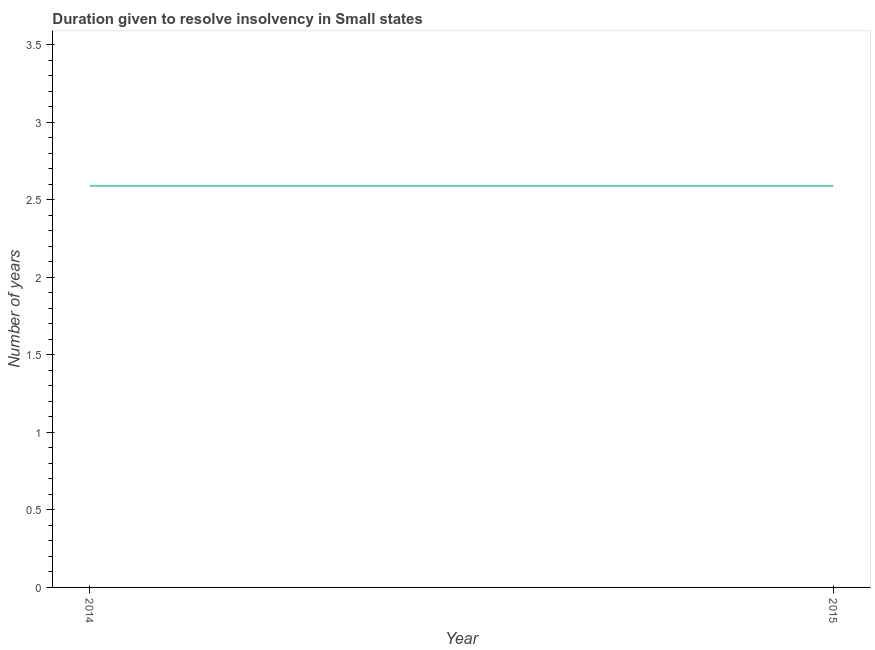What is the number of years to resolve insolvency in 2015?
Your answer should be very brief. 2.59. Across all years, what is the maximum number of years to resolve insolvency?
Provide a short and direct response. 2.59. Across all years, what is the minimum number of years to resolve insolvency?
Provide a short and direct response. 2.59. In which year was the number of years to resolve insolvency maximum?
Give a very brief answer. 2014. What is the sum of the number of years to resolve insolvency?
Keep it short and to the point. 5.18. What is the average number of years to resolve insolvency per year?
Keep it short and to the point. 2.59. What is the median number of years to resolve insolvency?
Offer a very short reply. 2.59. In how many years, is the number of years to resolve insolvency greater than 1.9 ?
Offer a terse response. 2. What is the ratio of the number of years to resolve insolvency in 2014 to that in 2015?
Your response must be concise. 1. Is the number of years to resolve insolvency in 2014 less than that in 2015?
Provide a short and direct response. No. Does the number of years to resolve insolvency monotonically increase over the years?
Give a very brief answer. No. What is the difference between two consecutive major ticks on the Y-axis?
Offer a terse response. 0.5. Are the values on the major ticks of Y-axis written in scientific E-notation?
Provide a succinct answer. No. Does the graph contain any zero values?
Your answer should be compact. No. Does the graph contain grids?
Your answer should be compact. No. What is the title of the graph?
Provide a succinct answer. Duration given to resolve insolvency in Small states. What is the label or title of the Y-axis?
Provide a short and direct response. Number of years. What is the Number of years of 2014?
Your response must be concise. 2.59. What is the Number of years in 2015?
Your answer should be compact. 2.59. What is the difference between the Number of years in 2014 and 2015?
Give a very brief answer. 0. 